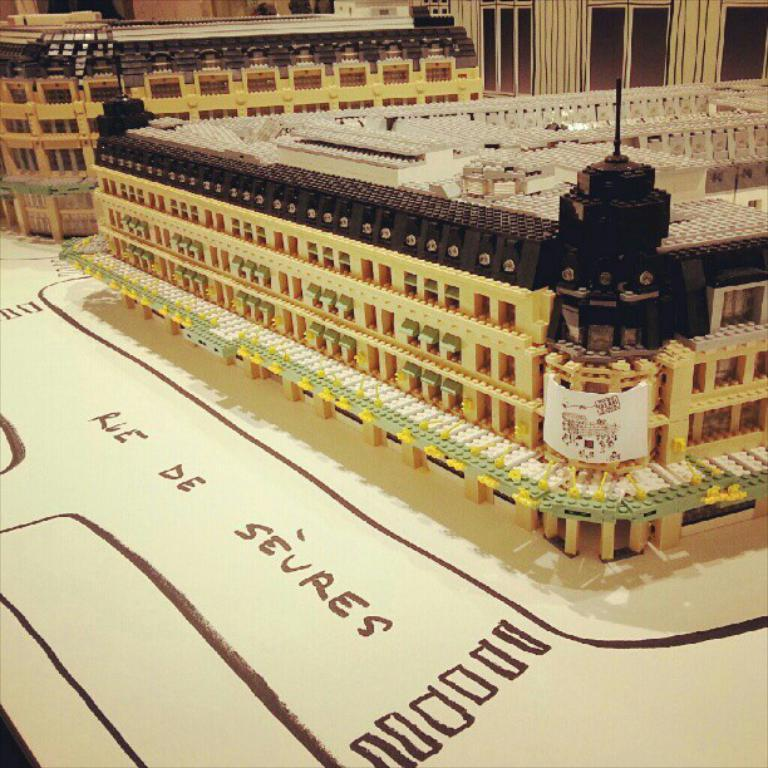What is the main subject of the image? The main subject of the image is a model of buildings. Is there any text present in the image? Yes, there is text written at the bottom of the image. Can you tell me how many times the person jumps in the image? There is no person visible in the image, and therefore no jumping activity can be observed. What type of drink is being consumed by the person in the image? There is no person or drink present in the image. 